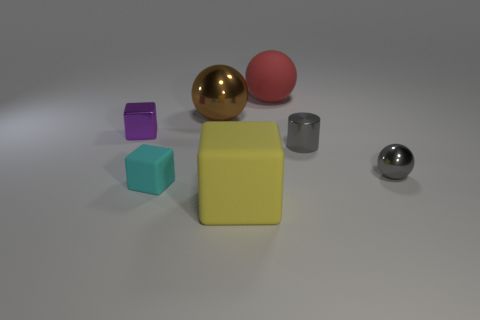Add 2 small cyan objects. How many objects exist? 9 Subtract all blocks. How many objects are left? 4 Add 2 large blue rubber objects. How many large blue rubber objects exist? 2 Subtract 1 brown spheres. How many objects are left? 6 Subtract all cyan rubber blocks. Subtract all large brown spheres. How many objects are left? 5 Add 5 large red rubber objects. How many large red rubber objects are left? 6 